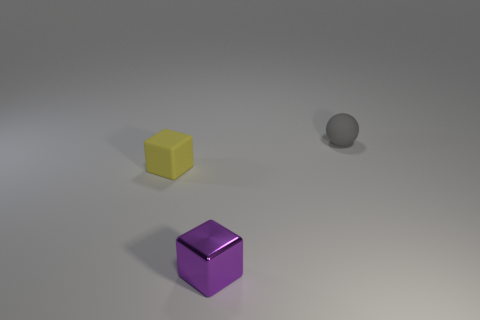Add 1 small purple metallic cubes. How many objects exist? 4 Subtract all purple balls. Subtract all purple blocks. How many balls are left? 1 Subtract all cubes. Subtract all small yellow rubber things. How many objects are left? 0 Add 3 cubes. How many cubes are left? 5 Add 1 small yellow objects. How many small yellow objects exist? 2 Subtract 0 red balls. How many objects are left? 3 Subtract all spheres. How many objects are left? 2 Subtract 1 balls. How many balls are left? 0 